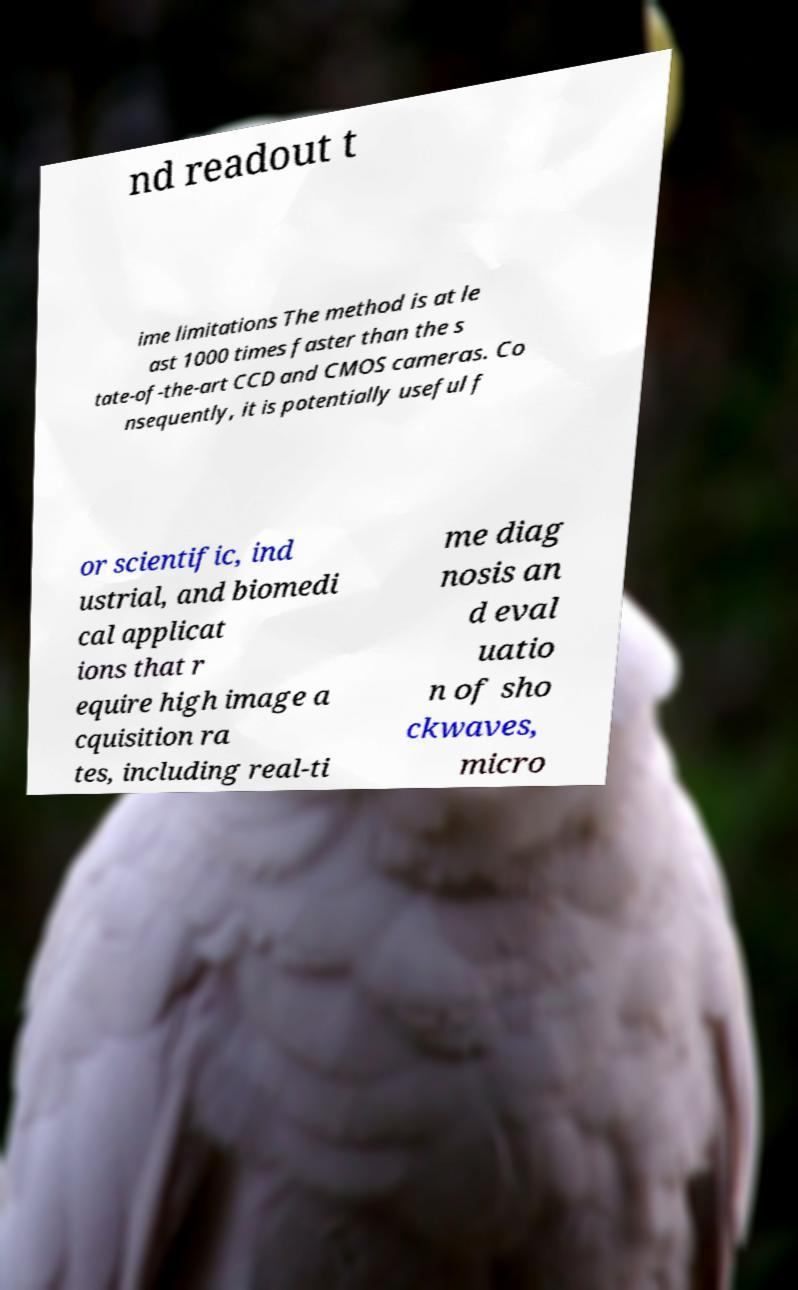There's text embedded in this image that I need extracted. Can you transcribe it verbatim? nd readout t ime limitations The method is at le ast 1000 times faster than the s tate-of-the-art CCD and CMOS cameras. Co nsequently, it is potentially useful f or scientific, ind ustrial, and biomedi cal applicat ions that r equire high image a cquisition ra tes, including real-ti me diag nosis an d eval uatio n of sho ckwaves, micro 